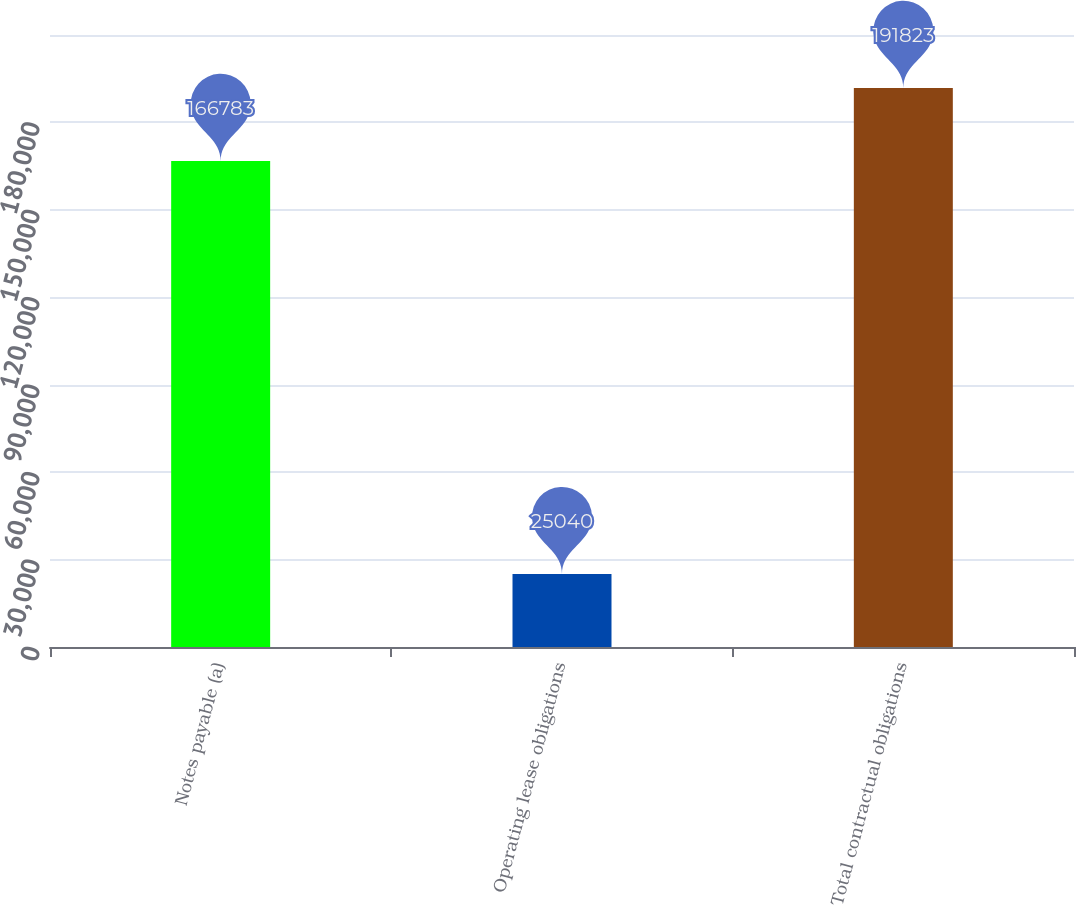Convert chart. <chart><loc_0><loc_0><loc_500><loc_500><bar_chart><fcel>Notes payable (a)<fcel>Operating lease obligations<fcel>Total contractual obligations<nl><fcel>166783<fcel>25040<fcel>191823<nl></chart> 